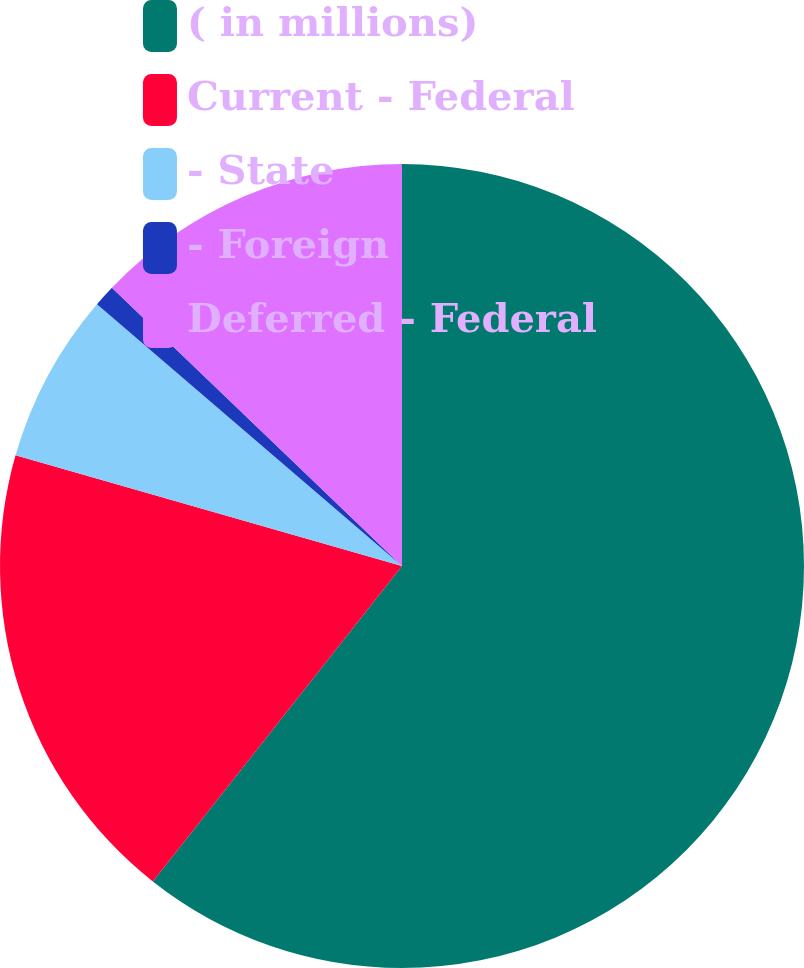Convert chart. <chart><loc_0><loc_0><loc_500><loc_500><pie_chart><fcel>( in millions)<fcel>Current - Federal<fcel>- State<fcel>- Foreign<fcel>Deferred - Federal<nl><fcel>60.64%<fcel>18.8%<fcel>6.85%<fcel>0.88%<fcel>12.83%<nl></chart> 